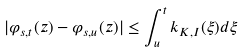<formula> <loc_0><loc_0><loc_500><loc_500>| \varphi _ { s , t } ( z ) - \varphi _ { s , u } ( z ) | \leq \int _ { u } ^ { t } k _ { K , I } ( \xi ) d \xi</formula> 